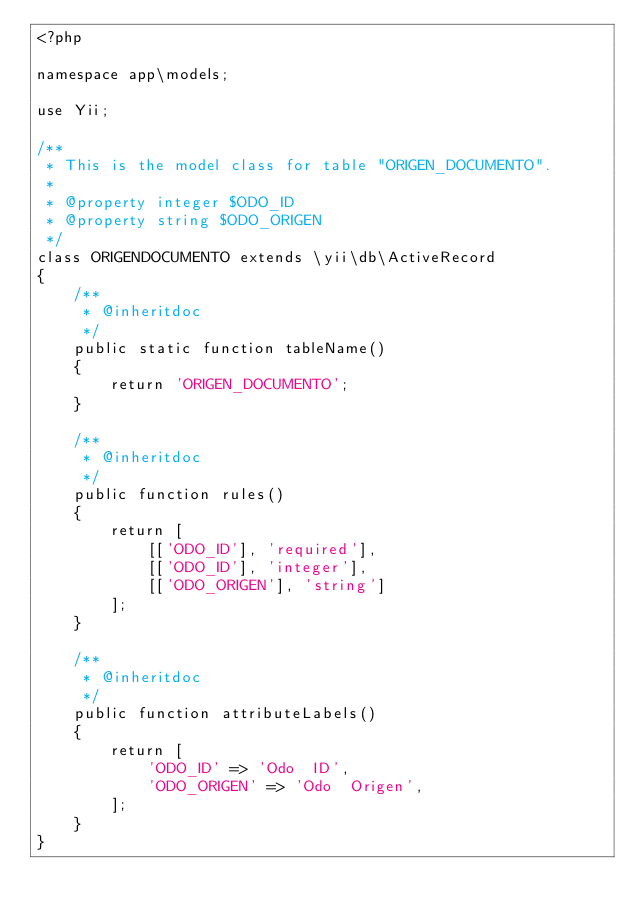Convert code to text. <code><loc_0><loc_0><loc_500><loc_500><_PHP_><?php

namespace app\models;

use Yii;

/**
 * This is the model class for table "ORIGEN_DOCUMENTO".
 *
 * @property integer $ODO_ID
 * @property string $ODO_ORIGEN
 */
class ORIGENDOCUMENTO extends \yii\db\ActiveRecord
{
    /**
     * @inheritdoc
     */
    public static function tableName()
    {
        return 'ORIGEN_DOCUMENTO';
    }

    /**
     * @inheritdoc
     */
    public function rules()
    {
        return [
            [['ODO_ID'], 'required'],
            [['ODO_ID'], 'integer'],
            [['ODO_ORIGEN'], 'string']
        ];
    }

    /**
     * @inheritdoc
     */
    public function attributeLabels()
    {
        return [
            'ODO_ID' => 'Odo  ID',
            'ODO_ORIGEN' => 'Odo  Origen',
        ];
    }
}
</code> 